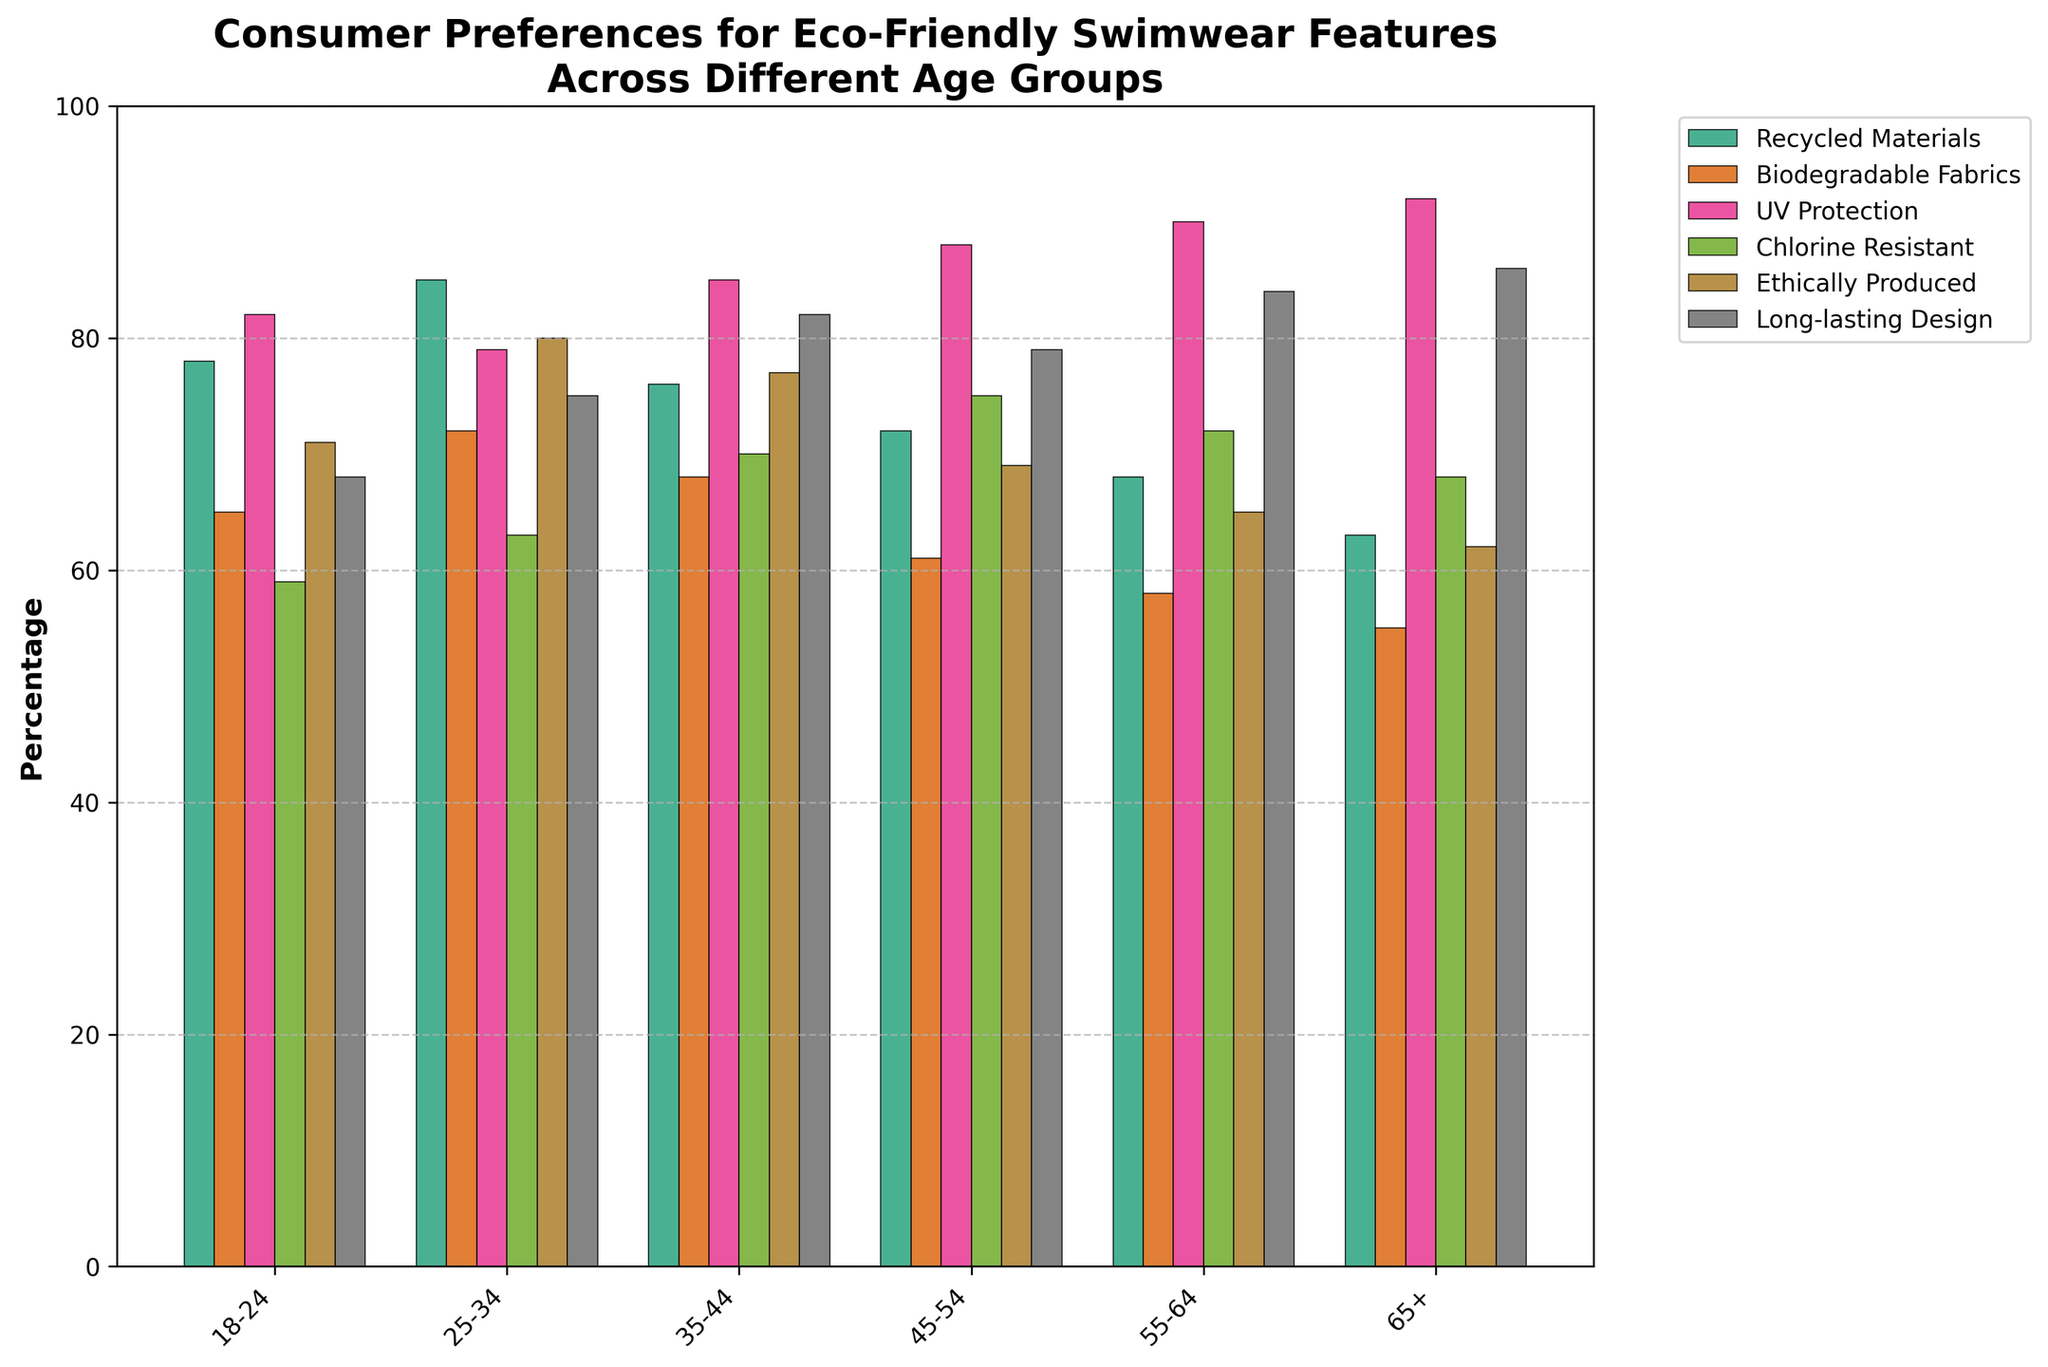What age group values UV Protection the most? Look at the bar heights for UV Protection across all age groups. The 65+ age group has the highest bar.
Answer: 65+ Which feature does the 18-24 age group prefer more: Recycled Materials or Chlorine Resistant? Compare the bar heights for Recycled Materials and Chlorine Resistant in the 18-24 age group. Recycled Materials has a higher bar.
Answer: Recycled Materials Among all features, which one is the least preferred by the 25-34 age group? Look at all bar heights for the 25-34 age group and find the smallest one. Biodegradable Fabrics has the lowest bar.
Answer: Biodegradable Fabrics How much higher is the preference for Long-lasting Design in the 55-64 age group compared to that in the 18-24 age group? Look at the bar heights for Long-lasting Design in both age groups and find the difference: 84% - 68% = 16%.
Answer: 16% Which age group has the highest preference for Ethically Produced swimwear? Identify the bar that represents Ethically Produced across all age groups and determine which one is the tallest. The 25-34 age group has the tallest bar.
Answer: 25-34 What is the average preference percentage for Biodegradable Fabrics across all age groups? Sum up the percentages for Biodegradable Fabrics across all age groups and divide by the number of age groups. (65% + 72% + 68% + 61% + 58% + 55%) / 6 = 63.17%.
Answer: 63.17% Is there an age group that prefers UV Protection more than Chlorine Resistant swimwear? If so, which one? Look at the UV Protection and Chlorine Resistant bars within each age group. All age groups have a higher bar for UV Protection than for Chlorine Resistant.
Answer: All age groups Which feature shows a consistent increase in preference as the age group increases? Look at the trend of the bar heights across age groups for each feature and find if any show a consistent increase. None of the features show a consistent increase; preferences fluctuate.
Answer: None 